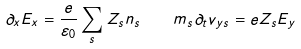<formula> <loc_0><loc_0><loc_500><loc_500>\partial _ { x } E _ { x } = \frac { e } { \varepsilon _ { 0 } } \sum _ { s } Z _ { s } n _ { s } \quad m _ { s } \partial _ { t } v _ { y s } = e Z _ { s } E _ { y }</formula> 